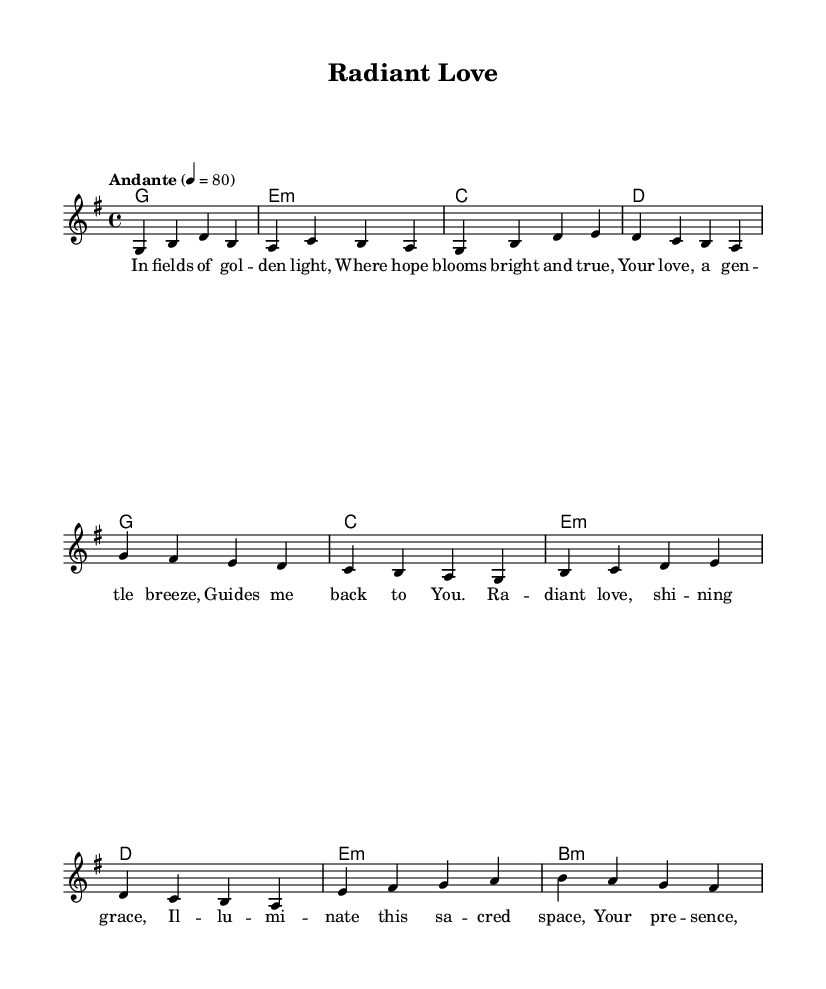What is the key signature of this music? The key signature is G major, which has one sharp (F#).
Answer: G major What is the time signature of this music? The time signature is four-four, which means there are four beats in each measure.
Answer: Four-four What is the tempo indication for this piece? The tempo is indicated as "Andante," which suggests a moderate pace.
Answer: Andante How many measures are there in the verse section? The verse consists of four measures, each containing various note values as per the melody line.
Answer: Four What is the main theme of the chorus lyrics? The chorus expresses the theme of divine love illuminating space and painting beauty, reflecting a reverent tone typical of contemporary hymns.
Answer: Radiant love What musical element is used in the bridge section? The bridge section utilizes imagery related to artistic expression, specifically referencing "brush strokes" and "colors," suggesting a deeper exploration of mercy and care.
Answer: Brush strokes of mercy Which chord is sustained through the first measure of the verse? The first measure of the verse holds the G major chord as the fundamental harmonic underpinning.
Answer: G major 